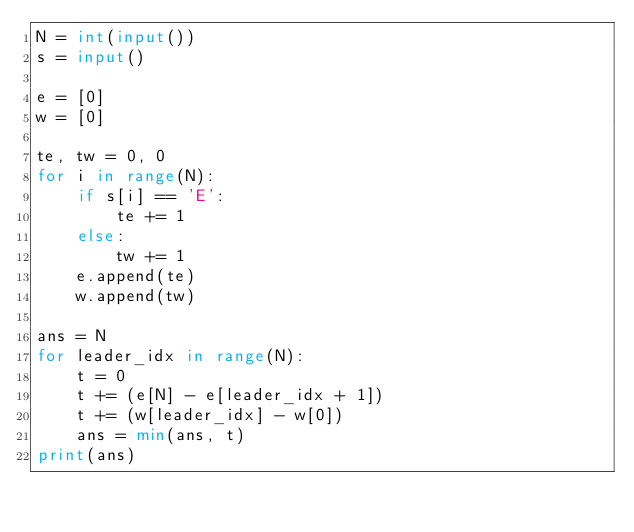<code> <loc_0><loc_0><loc_500><loc_500><_Python_>N = int(input())
s = input()

e = [0]
w = [0]

te, tw = 0, 0
for i in range(N):
    if s[i] == 'E':
        te += 1
    else:
        tw += 1
    e.append(te)
    w.append(tw)

ans = N
for leader_idx in range(N):
    t = 0
    t += (e[N] - e[leader_idx + 1])
    t += (w[leader_idx] - w[0])
    ans = min(ans, t)
print(ans)
</code> 